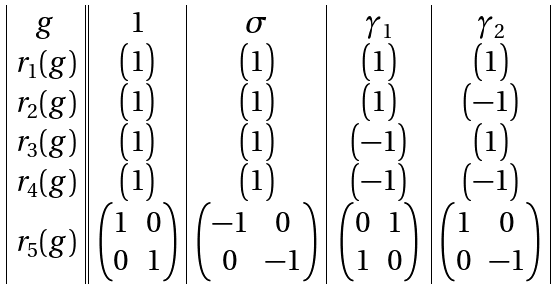Convert formula to latex. <formula><loc_0><loc_0><loc_500><loc_500>\begin{array} { | c | | c | c | c | c | } \strut g & \quad 1 \quad & \quad \sigma \quad & \quad \gamma _ { 1 } \quad & \quad \gamma _ { 2 } \quad \\ \strut r _ { 1 } ( g ) & \begin{pmatrix} 1 \end{pmatrix} & \begin{pmatrix} 1 \end{pmatrix} & \begin{pmatrix} 1 \end{pmatrix} & \begin{pmatrix} 1 \end{pmatrix} \\ r _ { 2 } ( g ) & \begin{pmatrix} 1 \end{pmatrix} & \begin{pmatrix} 1 \end{pmatrix} & \begin{pmatrix} 1 \end{pmatrix} & \begin{pmatrix} - 1 \end{pmatrix} \\ r _ { 3 } ( g ) & \begin{pmatrix} 1 \end{pmatrix} & \begin{pmatrix} 1 \end{pmatrix} & \begin{pmatrix} - 1 \end{pmatrix} & \begin{pmatrix} 1 \end{pmatrix} \\ r _ { 4 } ( g ) & \begin{pmatrix} 1 \end{pmatrix} & \begin{pmatrix} 1 \end{pmatrix} & \begin{pmatrix} - 1 \end{pmatrix} & \begin{pmatrix} - 1 \end{pmatrix} \\ r _ { 5 } ( g ) & \begin{pmatrix} 1 & 0 \\ 0 & 1 \end{pmatrix} & \begin{pmatrix} - 1 & 0 \\ 0 & - 1 \end{pmatrix} & \begin{pmatrix} 0 & 1 \\ 1 & 0 \end{pmatrix} & \begin{pmatrix} 1 & 0 \\ 0 & - 1 \end{pmatrix} \\ \end{array}</formula> 